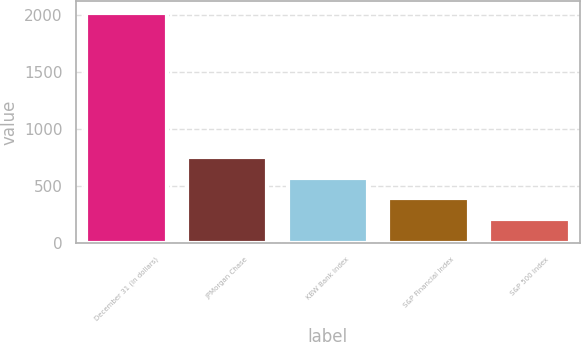Convert chart. <chart><loc_0><loc_0><loc_500><loc_500><bar_chart><fcel>December 31 (in dollars)<fcel>JPMorgan Chase<fcel>KBW Bank Index<fcel>S&P Financial Index<fcel>S&P 500 Index<nl><fcel>2017<fcel>750.75<fcel>569.85<fcel>388.95<fcel>208.05<nl></chart> 